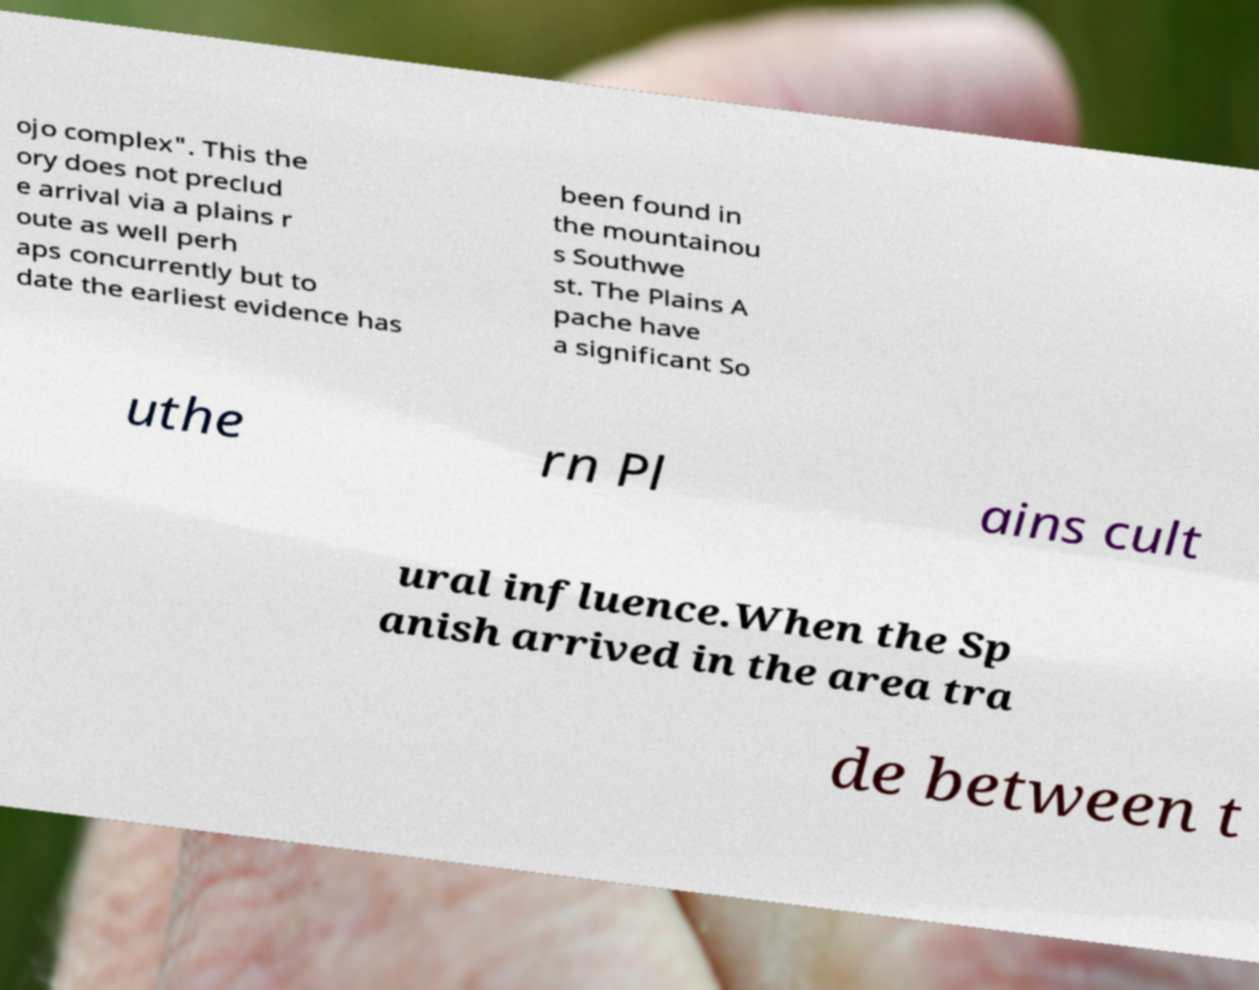Could you extract and type out the text from this image? ojo complex". This the ory does not preclud e arrival via a plains r oute as well perh aps concurrently but to date the earliest evidence has been found in the mountainou s Southwe st. The Plains A pache have a significant So uthe rn Pl ains cult ural influence.When the Sp anish arrived in the area tra de between t 